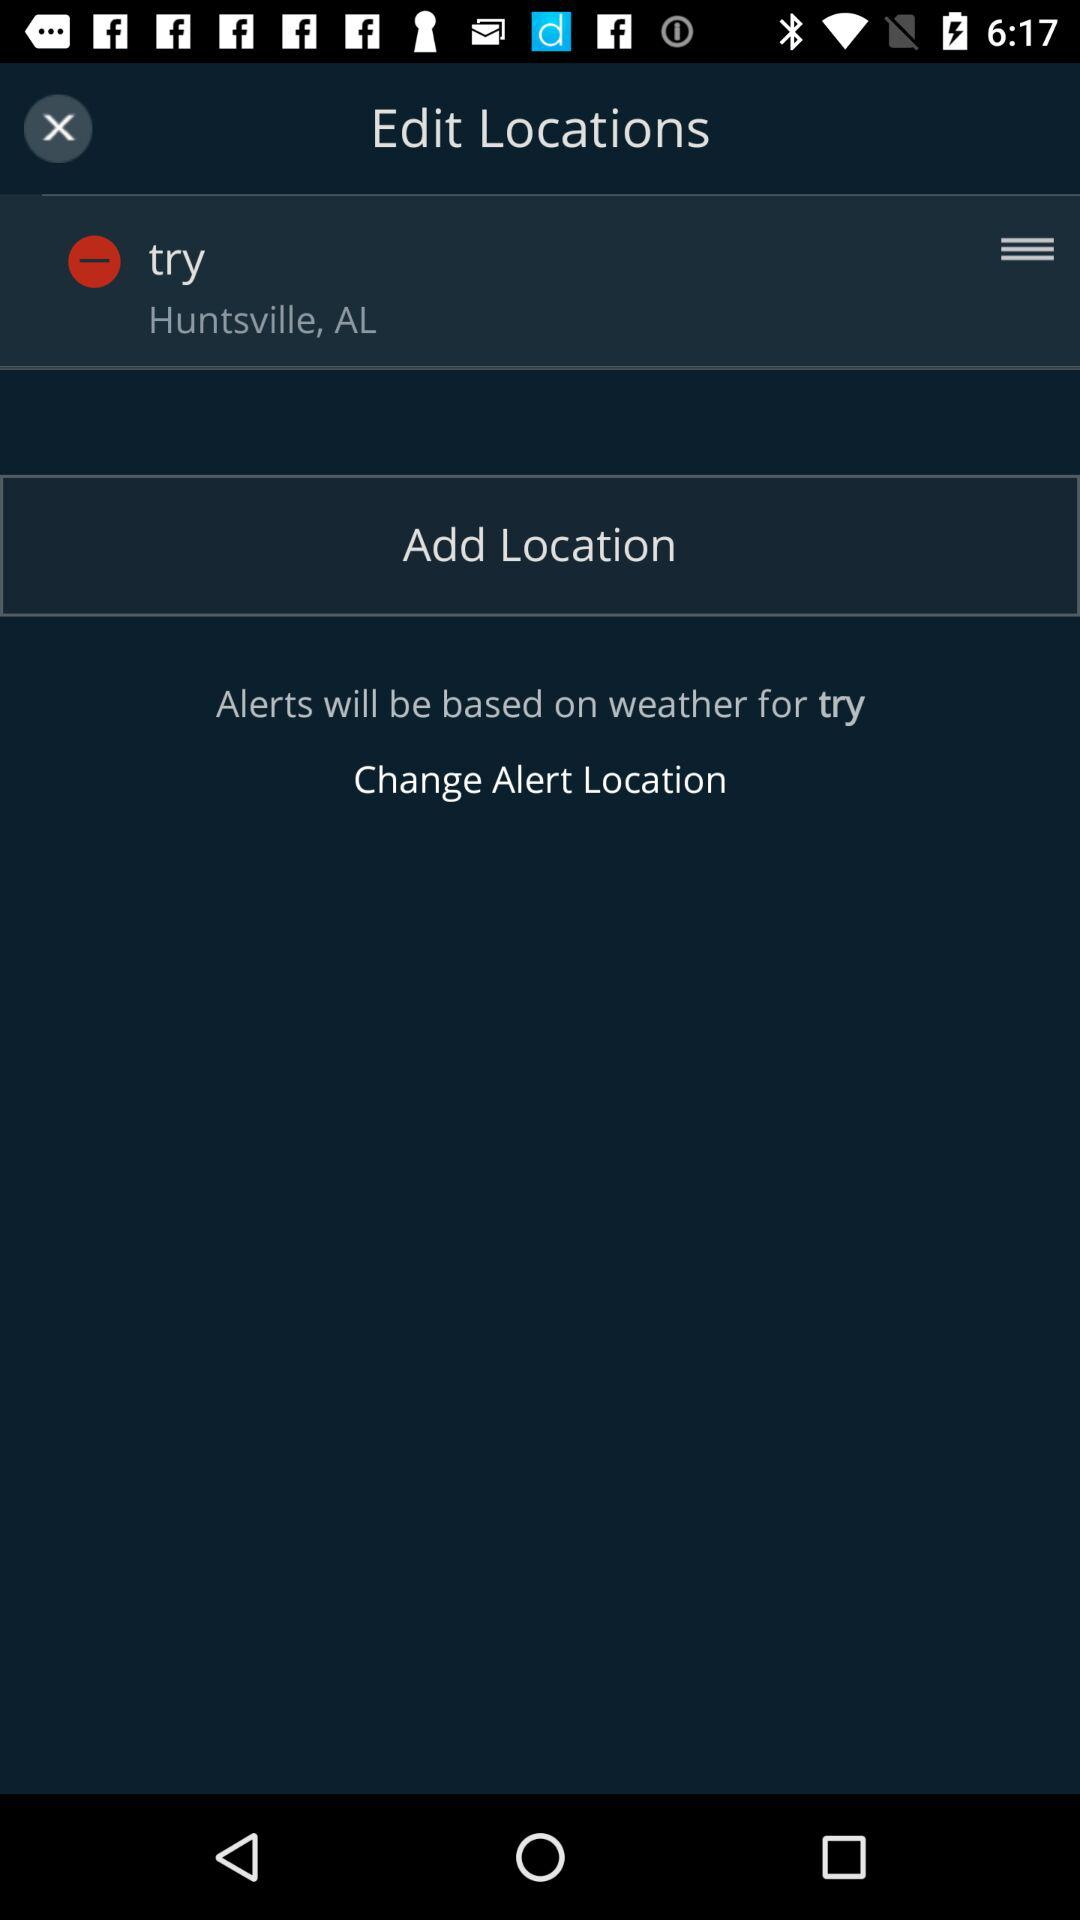What's the location? The location is Huntsville, AL. 